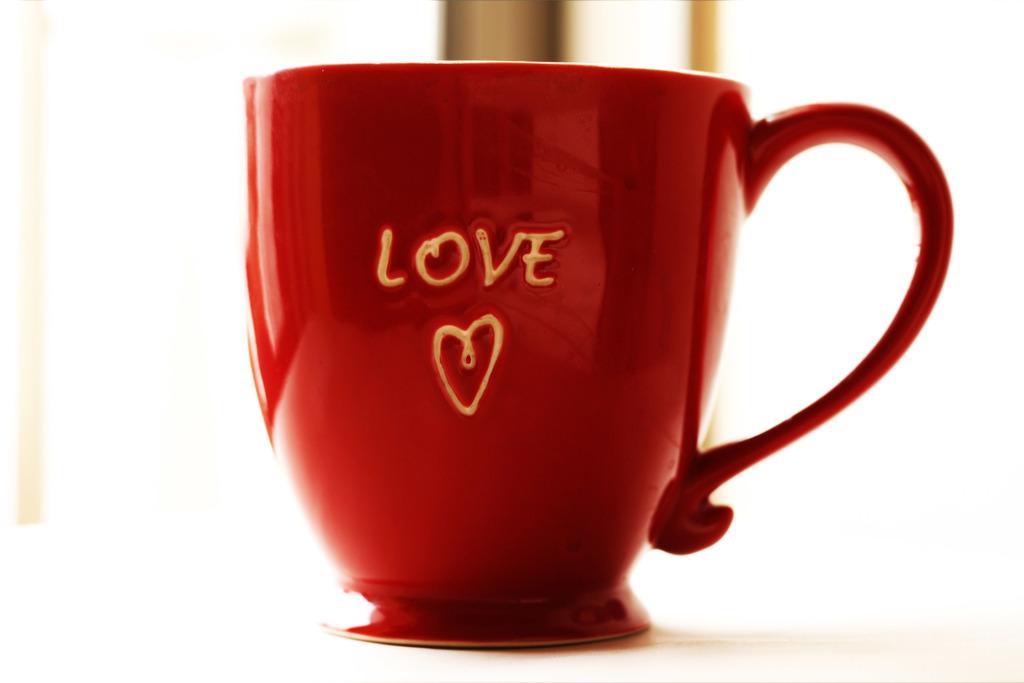Describe this image in one or two sentences. In the image there is a red cup and on that cup it is written as ¨LOVE¨. 